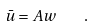Convert formula to latex. <formula><loc_0><loc_0><loc_500><loc_500>\bar { u } = A w \quad .</formula> 